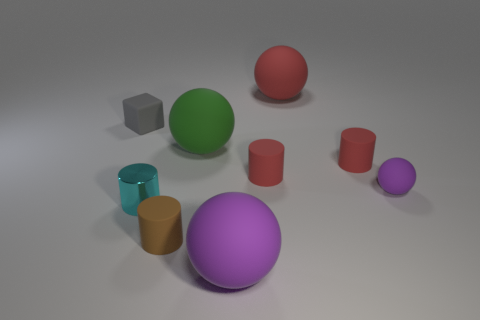Are there any other things that are made of the same material as the tiny cyan object?
Keep it short and to the point. No. The small matte thing that is in front of the purple matte object behind the big rubber sphere in front of the green matte sphere is what shape?
Keep it short and to the point. Cylinder. There is a small object that is to the left of the brown matte thing and in front of the gray object; what is its material?
Make the answer very short. Metal. There is a red object that is behind the gray block; does it have the same size as the big purple thing?
Offer a terse response. Yes. Is the number of small brown things that are in front of the red ball greater than the number of large spheres on the left side of the small brown rubber cylinder?
Your answer should be compact. Yes. There is a big matte ball in front of the purple sphere on the right side of the purple rubber object that is in front of the tiny ball; what is its color?
Make the answer very short. Purple. Is the color of the big matte sphere that is in front of the tiny cyan thing the same as the tiny ball?
Offer a very short reply. Yes. How many other objects are there of the same color as the small shiny object?
Keep it short and to the point. 0. What number of objects are either brown cylinders or small matte things?
Your response must be concise. 5. What number of things are blue metallic spheres or small cylinders that are behind the brown rubber thing?
Provide a succinct answer. 3. 